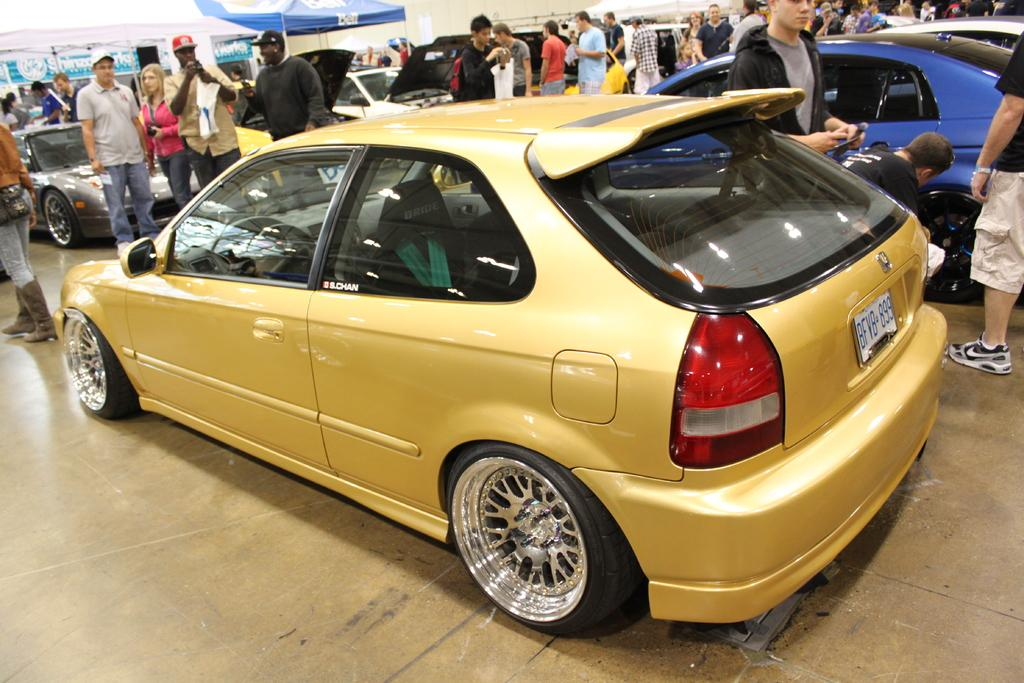What types of objects are present in the image? There are vehicles, a group of people, banners, and gazebo tents in the image. Can you describe the vehicles in the image? Unfortunately, the facts provided do not give specific details about the vehicles. What might the group of people be doing in the image? The group of people could be attending an event or gathering, as there are banners and gazebo tents present. What are the banners used for in the image? The banners might be used for advertising, promoting, or providing information about an event or gathering. How many gazebo tents are visible in the image? The facts provided do not specify the exact number of gazebo tents in the image. What type of stone is being used to cook the meat in the image? There is no stone or meat present in the image; it features vehicles, a group of people, banners, and gazebo tents. What advice is being given to the person standing near the banner in the image? The facts provided do not give any information about advice being given in the image. 